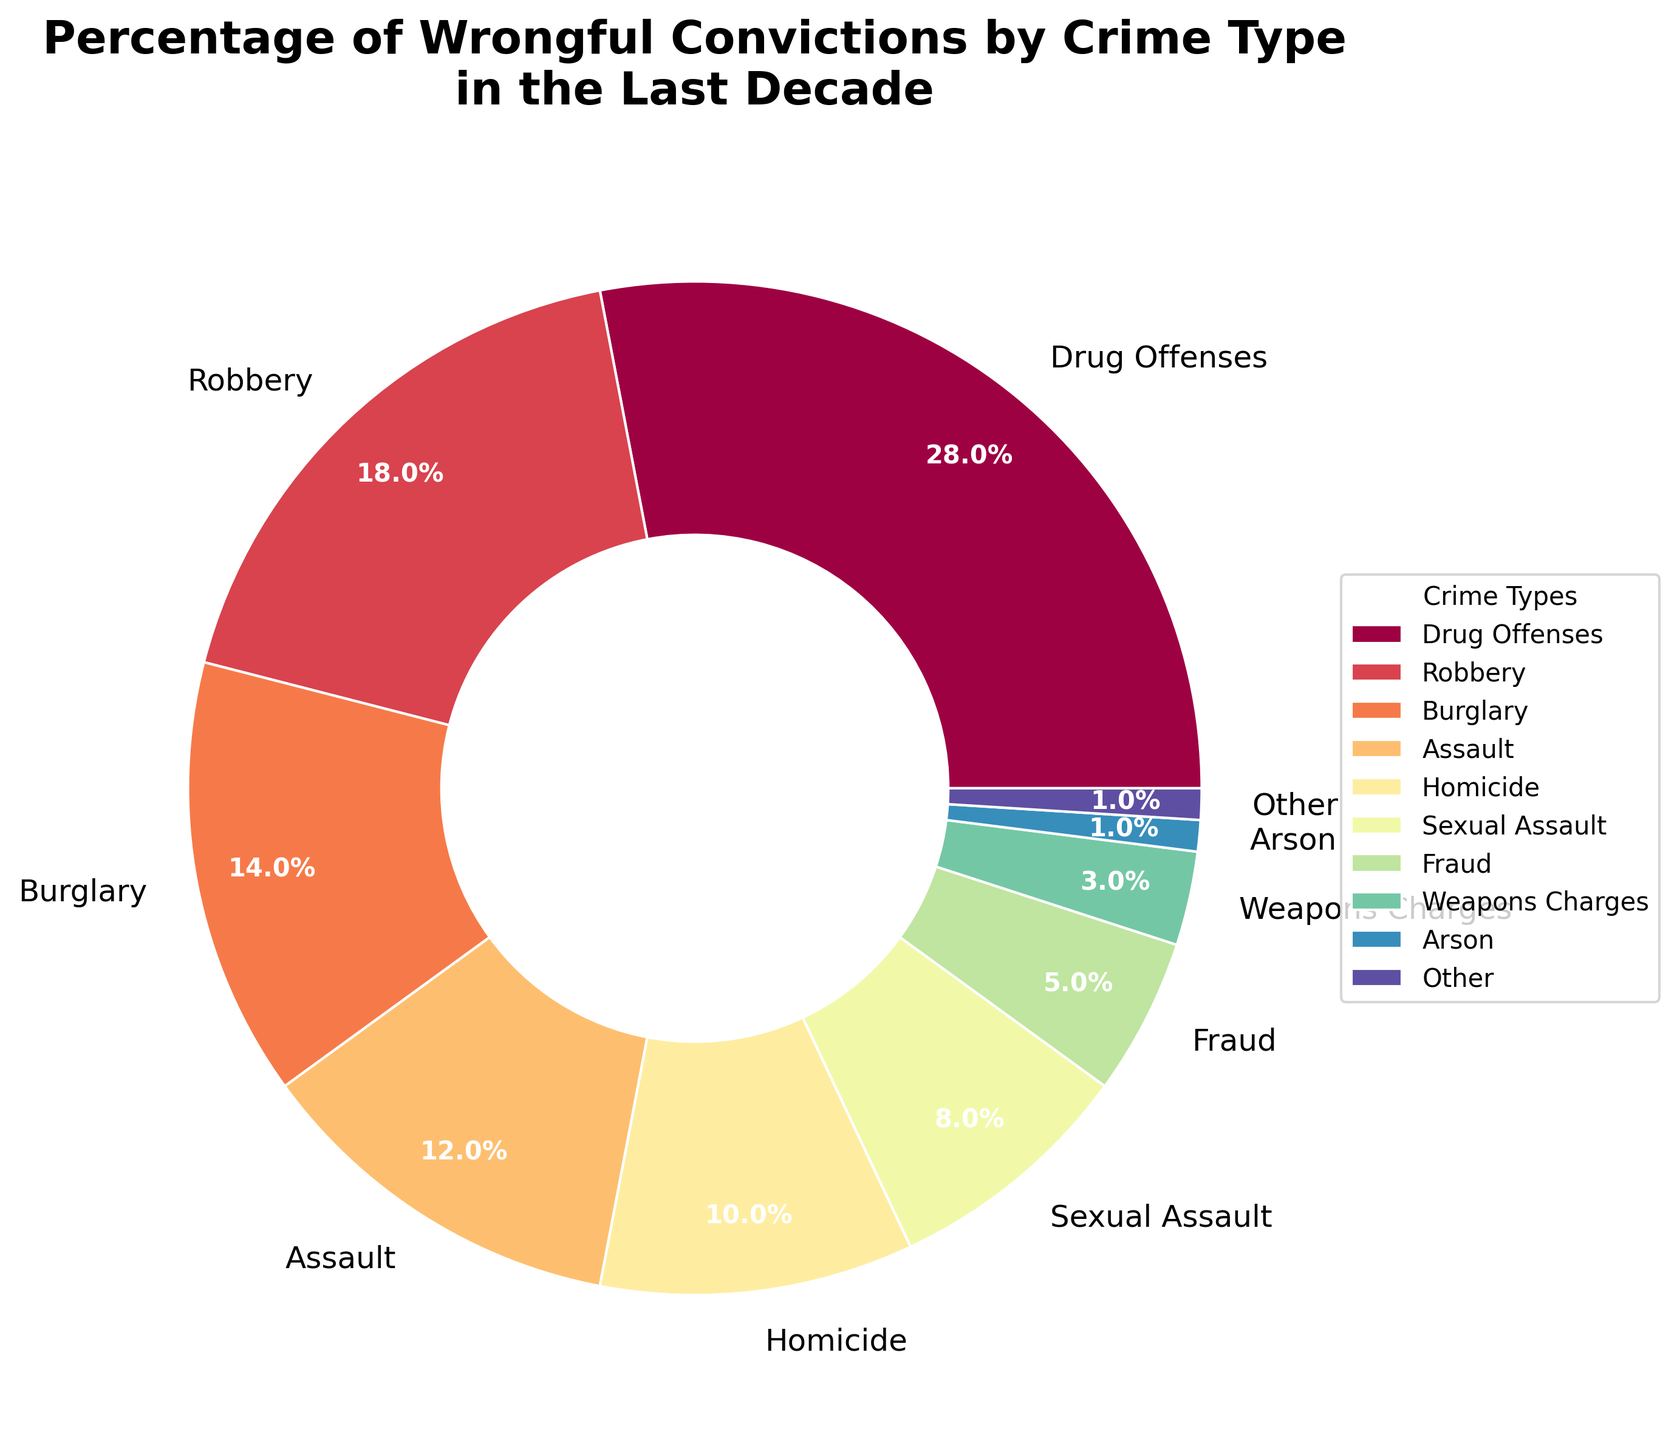Which crime type has the highest percentage of wrongful convictions? The figure shows that Drug Offenses have the largest section in the pie chart, labeled with 28%.
Answer: Drug Offenses What is the combined percentage of wrongful convictions for Robbery and Burglary? Adding the percentages for Robbery (18%) and Burglary (14%) results in a total of 32%.
Answer: 32% How much larger is the percentage of wrongful convictions for Drug Offenses compared to Homicide? The percentage for Drug Offenses is 28%, and for Homicide, it is 10%. The difference is 28% - 10% = 18%.
Answer: 18% Which crime type has the smallest percentage of wrongful convictions, and what is it? The smallest slice of the pie chart represents Arson and Other, each labeled with 1%.
Answer: Arson and Other, 1% What is the average percentage of wrongful convictions for Assault, Homicide, and Sexual Assault? Summing the percentages: Assault (12%), Homicide (10%), and Sexual Assault (8%) gives 12 + 10 + 8 = 30. Dividing by 3, we get an average of 30 / 3 = 10%.
Answer: 10% Which crime has a higher percentage of wrongful convictions: Fraud or Weapons Charges? The pie chart shows that Fraud is labeled with 5%, and Weapons Charges with 3%. Thus, Fraud has a higher percentage.
Answer: Fraud What is the difference between the combined percentage of Assault and Burglary compared to Homicide and Sexual Assault? Adding Assault (12%) and Burglary (14%) gives 26%. Adding Homicide (10%) and Sexual Assault (8%) gives 18%. The difference is 26% - 18% = 8%.
Answer: 8% What color is used to represent the Robbery slice in the pie chart? The Robbery slice is depicted using one of the colors from the Spectral color map, which is visible in the pie chart. The exact hue may vary, but it can be visually identified in the pie chart.
Answer: Varies (depends on palette) Which three crime types have a combined percentage closest to 50%? Combining percentages for Drug Offenses (28%), Robbery (18%), and Burglary (14%) gives 28 + 18 + 14 = 60%. Combining Drug Offenses (28%), Robbery (18%), and Assault (12%) gives 28 + 18 + 12 = 58%. The closer combination is Robbery (18%), Burglary (14%), and Assault (12%) which sums to 44%. The combination pair of Drug Offenses and Fraud give 28%+18%=46%.
Answer: Robbery, Burglary, Assault, 44% 